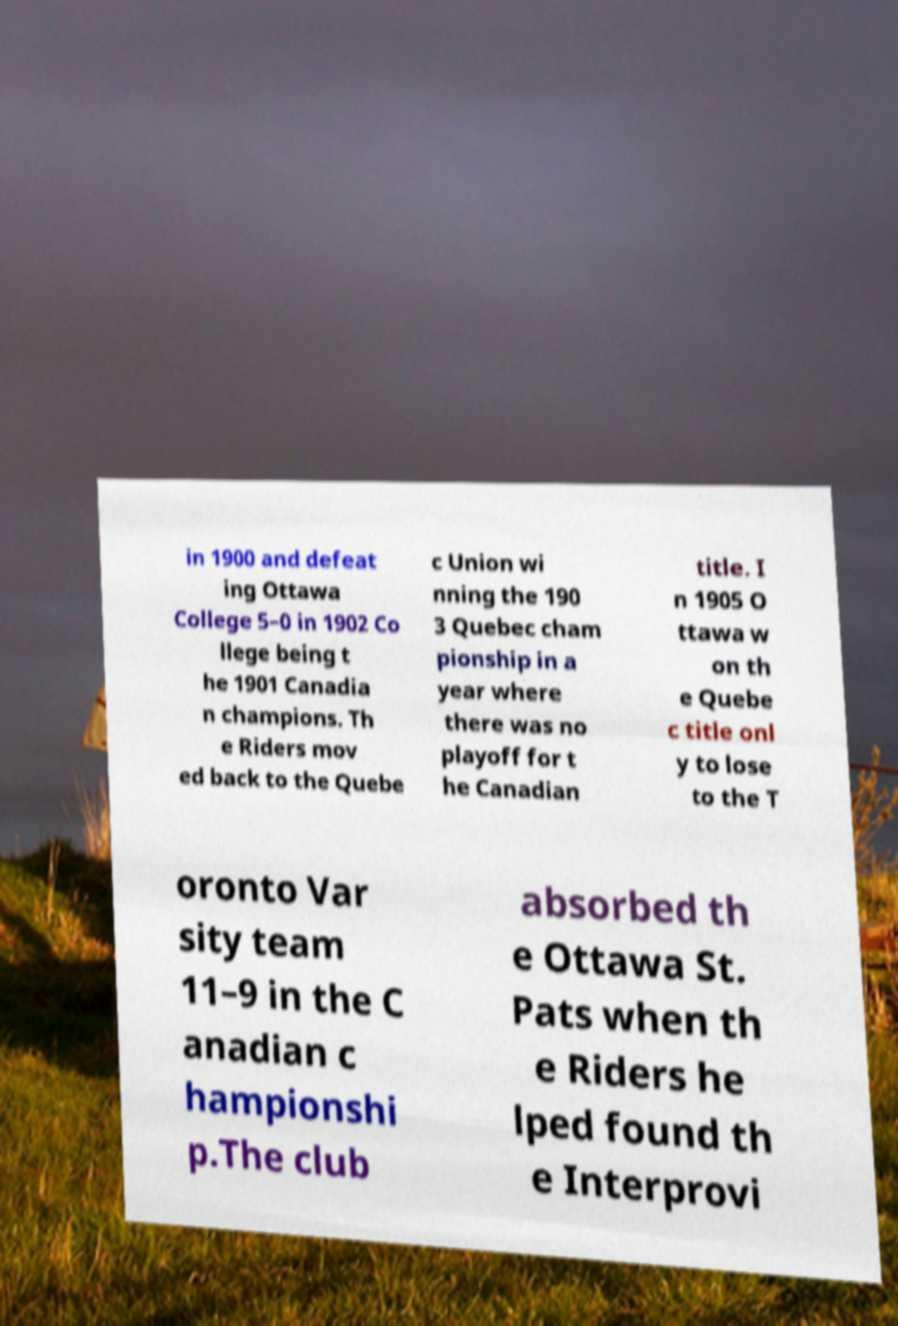Can you accurately transcribe the text from the provided image for me? in 1900 and defeat ing Ottawa College 5–0 in 1902 Co llege being t he 1901 Canadia n champions. Th e Riders mov ed back to the Quebe c Union wi nning the 190 3 Quebec cham pionship in a year where there was no playoff for t he Canadian title. I n 1905 O ttawa w on th e Quebe c title onl y to lose to the T oronto Var sity team 11–9 in the C anadian c hampionshi p.The club absorbed th e Ottawa St. Pats when th e Riders he lped found th e Interprovi 